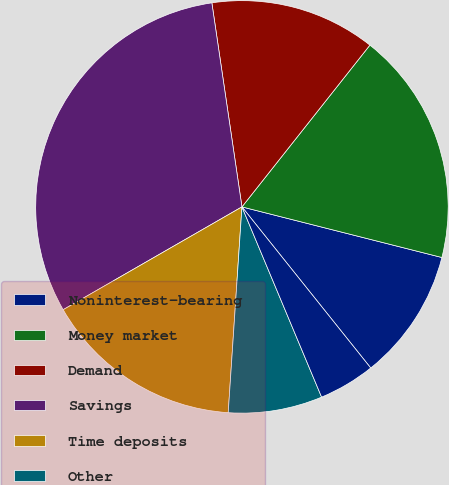Convert chart to OTSL. <chart><loc_0><loc_0><loc_500><loc_500><pie_chart><fcel>Noninterest-bearing<fcel>Money market<fcel>Demand<fcel>Savings<fcel>Time deposits<fcel>Other<fcel>Total borrowed funds<nl><fcel>10.32%<fcel>18.29%<fcel>12.98%<fcel>30.97%<fcel>15.63%<fcel>7.37%<fcel>4.42%<nl></chart> 